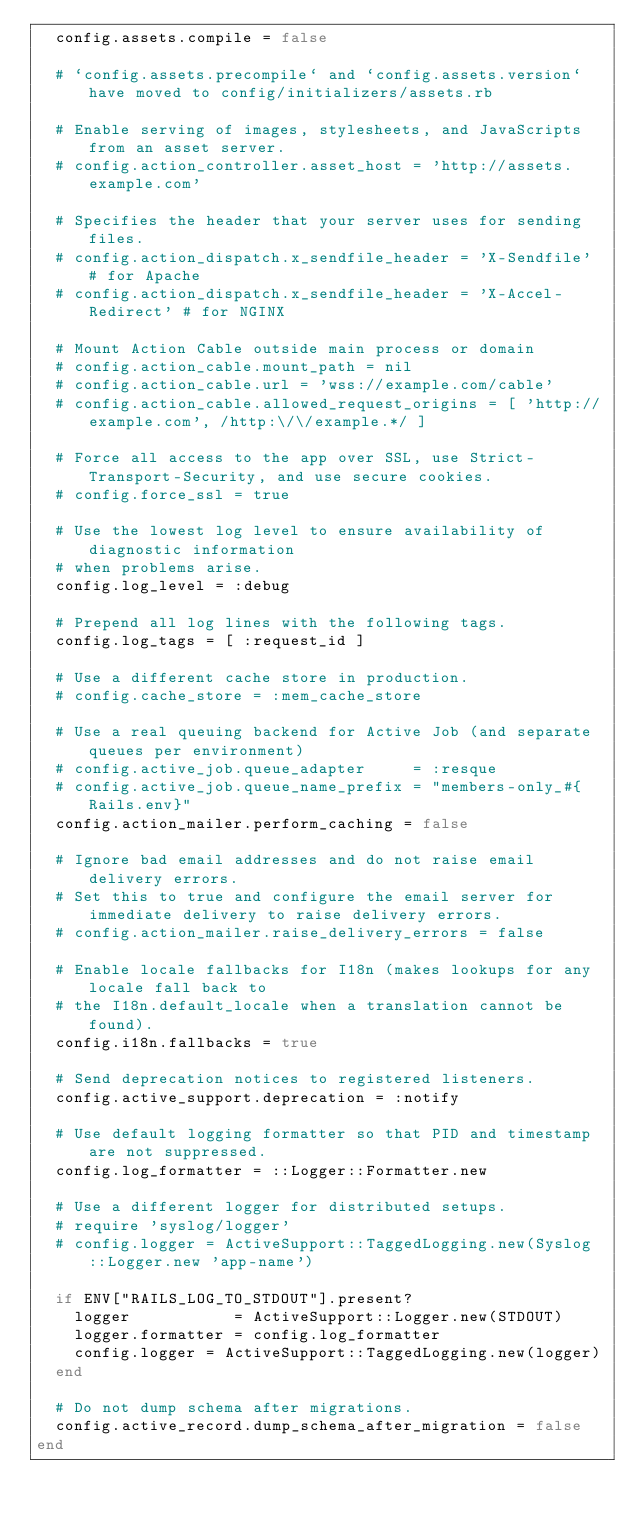<code> <loc_0><loc_0><loc_500><loc_500><_Ruby_>  config.assets.compile = false

  # `config.assets.precompile` and `config.assets.version` have moved to config/initializers/assets.rb

  # Enable serving of images, stylesheets, and JavaScripts from an asset server.
  # config.action_controller.asset_host = 'http://assets.example.com'

  # Specifies the header that your server uses for sending files.
  # config.action_dispatch.x_sendfile_header = 'X-Sendfile' # for Apache
  # config.action_dispatch.x_sendfile_header = 'X-Accel-Redirect' # for NGINX

  # Mount Action Cable outside main process or domain
  # config.action_cable.mount_path = nil
  # config.action_cable.url = 'wss://example.com/cable'
  # config.action_cable.allowed_request_origins = [ 'http://example.com', /http:\/\/example.*/ ]

  # Force all access to the app over SSL, use Strict-Transport-Security, and use secure cookies.
  # config.force_ssl = true

  # Use the lowest log level to ensure availability of diagnostic information
  # when problems arise.
  config.log_level = :debug

  # Prepend all log lines with the following tags.
  config.log_tags = [ :request_id ]

  # Use a different cache store in production.
  # config.cache_store = :mem_cache_store

  # Use a real queuing backend for Active Job (and separate queues per environment)
  # config.active_job.queue_adapter     = :resque
  # config.active_job.queue_name_prefix = "members-only_#{Rails.env}"
  config.action_mailer.perform_caching = false

  # Ignore bad email addresses and do not raise email delivery errors.
  # Set this to true and configure the email server for immediate delivery to raise delivery errors.
  # config.action_mailer.raise_delivery_errors = false

  # Enable locale fallbacks for I18n (makes lookups for any locale fall back to
  # the I18n.default_locale when a translation cannot be found).
  config.i18n.fallbacks = true

  # Send deprecation notices to registered listeners.
  config.active_support.deprecation = :notify

  # Use default logging formatter so that PID and timestamp are not suppressed.
  config.log_formatter = ::Logger::Formatter.new

  # Use a different logger for distributed setups.
  # require 'syslog/logger'
  # config.logger = ActiveSupport::TaggedLogging.new(Syslog::Logger.new 'app-name')

  if ENV["RAILS_LOG_TO_STDOUT"].present?
    logger           = ActiveSupport::Logger.new(STDOUT)
    logger.formatter = config.log_formatter
    config.logger = ActiveSupport::TaggedLogging.new(logger)
  end

  # Do not dump schema after migrations.
  config.active_record.dump_schema_after_migration = false
end
</code> 